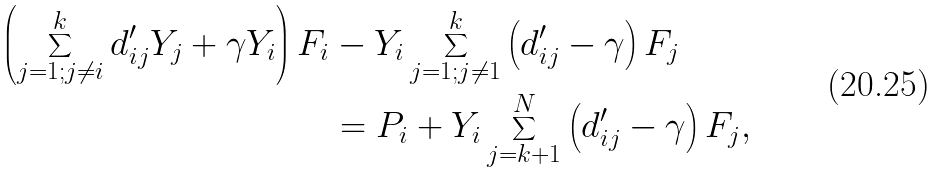<formula> <loc_0><loc_0><loc_500><loc_500>\left ( \sum ^ { k } _ { j = 1 ; j \not = i } d ^ { \prime } _ { i j } Y _ { j } + \gamma Y _ { i } \right ) F _ { i } & - Y _ { i } \sum ^ { k } _ { j = 1 ; j \not = 1 } \left ( d ^ { \prime } _ { i j } - \gamma \right ) F _ { j } \\ & = P _ { i } + Y _ { i } \sum ^ { N } _ { j = k + 1 } \left ( d ^ { \prime } _ { i j } - \gamma \right ) F _ { j } ,</formula> 